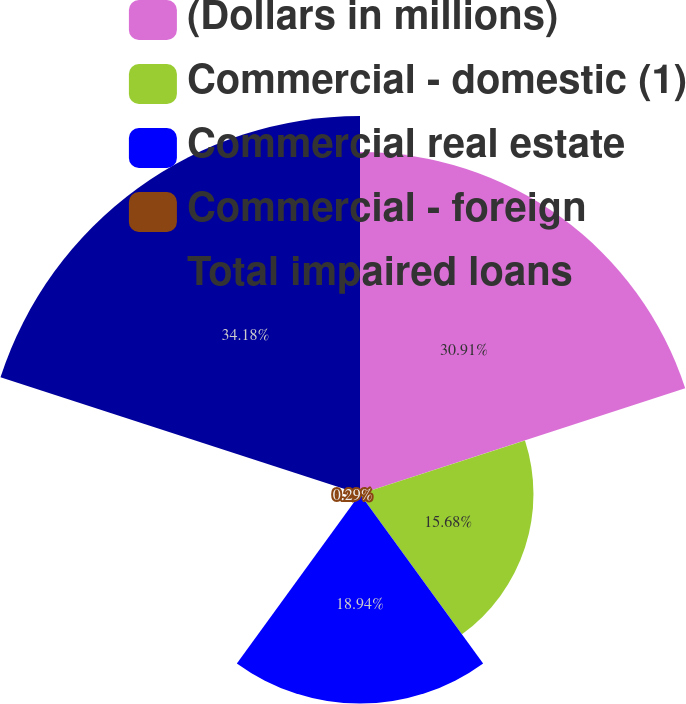Convert chart. <chart><loc_0><loc_0><loc_500><loc_500><pie_chart><fcel>(Dollars in millions)<fcel>Commercial - domestic (1)<fcel>Commercial real estate<fcel>Commercial - foreign<fcel>Total impaired loans<nl><fcel>30.91%<fcel>15.68%<fcel>18.94%<fcel>0.29%<fcel>34.17%<nl></chart> 